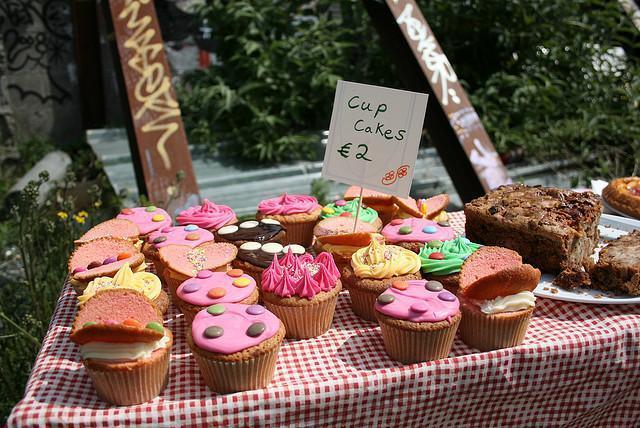How many cakes are in the photo?
Give a very brief answer. 12. How many zebras can you count?
Give a very brief answer. 0. 